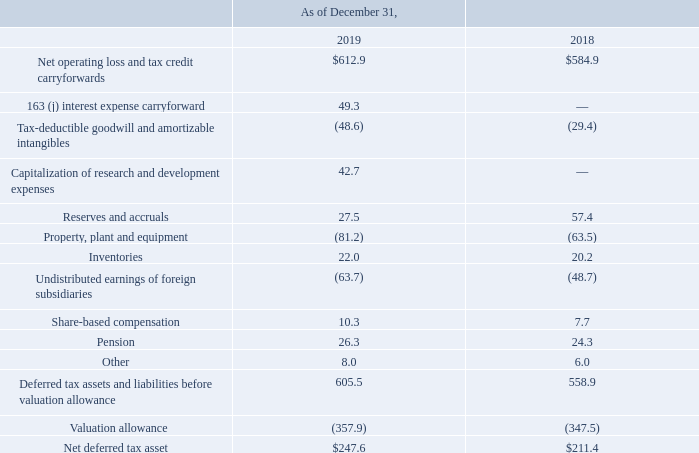The tax effects of temporary differences in the recognition of income and expense for tax and financial reporting purposes that give rise to significant portions of the net deferred tax asset (liability) are as follows (in millions):
As of December 31, 2019 and 2018, the Company had approximately $521.9 million and $768.9 million, respectively, of federal NOL carryforwards, before reduction for unrecognized tax benefits, which are subject to annual limitations prescribed in Section 382 of the Internal Revenue Code. The decrease is due to current year utilization. If not utilized, a portion of the NOLs will expire in varying amounts from 2024 to 2036; however, a small portion of the NOL that was generated after December 31, 2017 is carried forward indefinitely.
As of December 31, 2019 and 2018, the Company had approximately $134.5 million and $83.7 million, respectively, of federal credit carryforwards, before consideration of valuation allowance or reduction for unrecognized tax benefits, which are subject to annual limitations prescribed in Section 383 of the Internal Revenue Code. If not utilized, the credits will expire in varying amounts from 2028 to 2039.
As of December 31, 2019 and 2018, the Company had approximately $825.8 million and $801.0 million, respectively, of state NOL carryforwards, before consideration of valuation allowance or reduction for unrecognized tax benefits. If not utilized, a portion of the NOLs will expire in varying amounts starting in 2020.
Certain states have adopted the federal rule allowing unlimited NOL carryover for NOLs generated in tax years beginning after December 31, 2017. Therefore, a portion of the state NOLs generated after 2017 carry forward indefinitely. As of December 31, 2019 and 2018, the Company had $138.6 million and $115.8 million, respectively, of state credit carryforwards before consideration of valuation allowance or reduction for unrecognized tax benefits. If not utilized, a portion of the credits will begin to expire in varying amounts starting in 2020.
As of December 31, 2019 and 2018, the Company had approximately $757.1 million and $734.4 million, respectively, of foreign NOL carryforwards, before consideration of valuation allowance. If not utilized, a portion of the NOLs will begin to expire in varying amounts starting in 2020. A significant portion of these NOLs will expire by 2025.
As of December 31, 2019 and 2018, the Company had $76.8 million and $68.8 million, respectively, of foreign credit carryforwards before consideration of valuation allowance. If not utilized, the majority of these credits will expire by 2026.
The Company continues to maintain a valuation allowance of $186.3 million on a portion of its Japan NOLs, which expire in varying amounts from 2020 to 2024. In addition to the valuation allowance mentioned above on Japan NOLs, the Company continues to maintain a full valuation allowance on its U.S. state deferred tax assets, and a valuation allowance on foreign NOLs and tax credits in certain other foreign jurisdictions.
How much was the foreign credit carryforwards before consideration of valuation allowance as of December 31, 2019? $76.8 million. How much was the foreign credit carryforwards before consideration of valuation allowance as of December 31, 2018? $68.8 million. When does the credits expire if they are not utilized? 2026. What is the change in Net operating loss and tax credit carryforwards from December 31, 2018 to 2019?
Answer scale should be: million. 612.9-584.9
Answer: 28. What is the change in Reserves and accruals from year ended December 31, 2018 to 2019?
Answer scale should be: million. 27.5-57.4
Answer: -29.9. What is the average Net operating loss and tax credit carryforwards for December 31, 2018 and 2019?
Answer scale should be: million. (612.9+584.9) / 2
Answer: 598.9. 